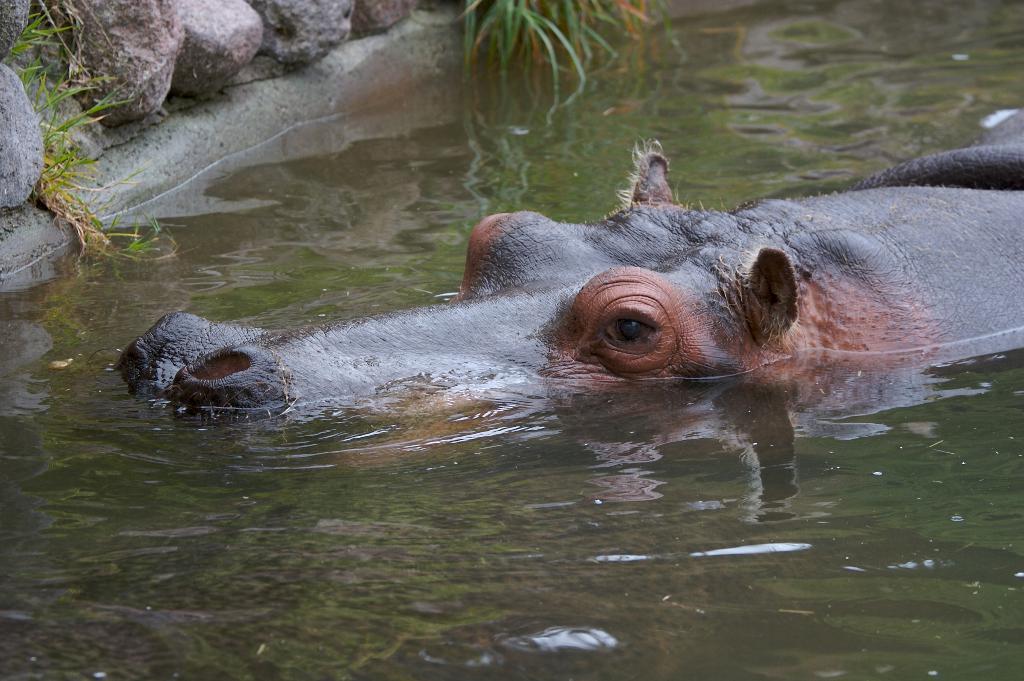Can you describe this image briefly? In this image there is a hippopotamus in the water. In the background there are stones and a grass in the water. 